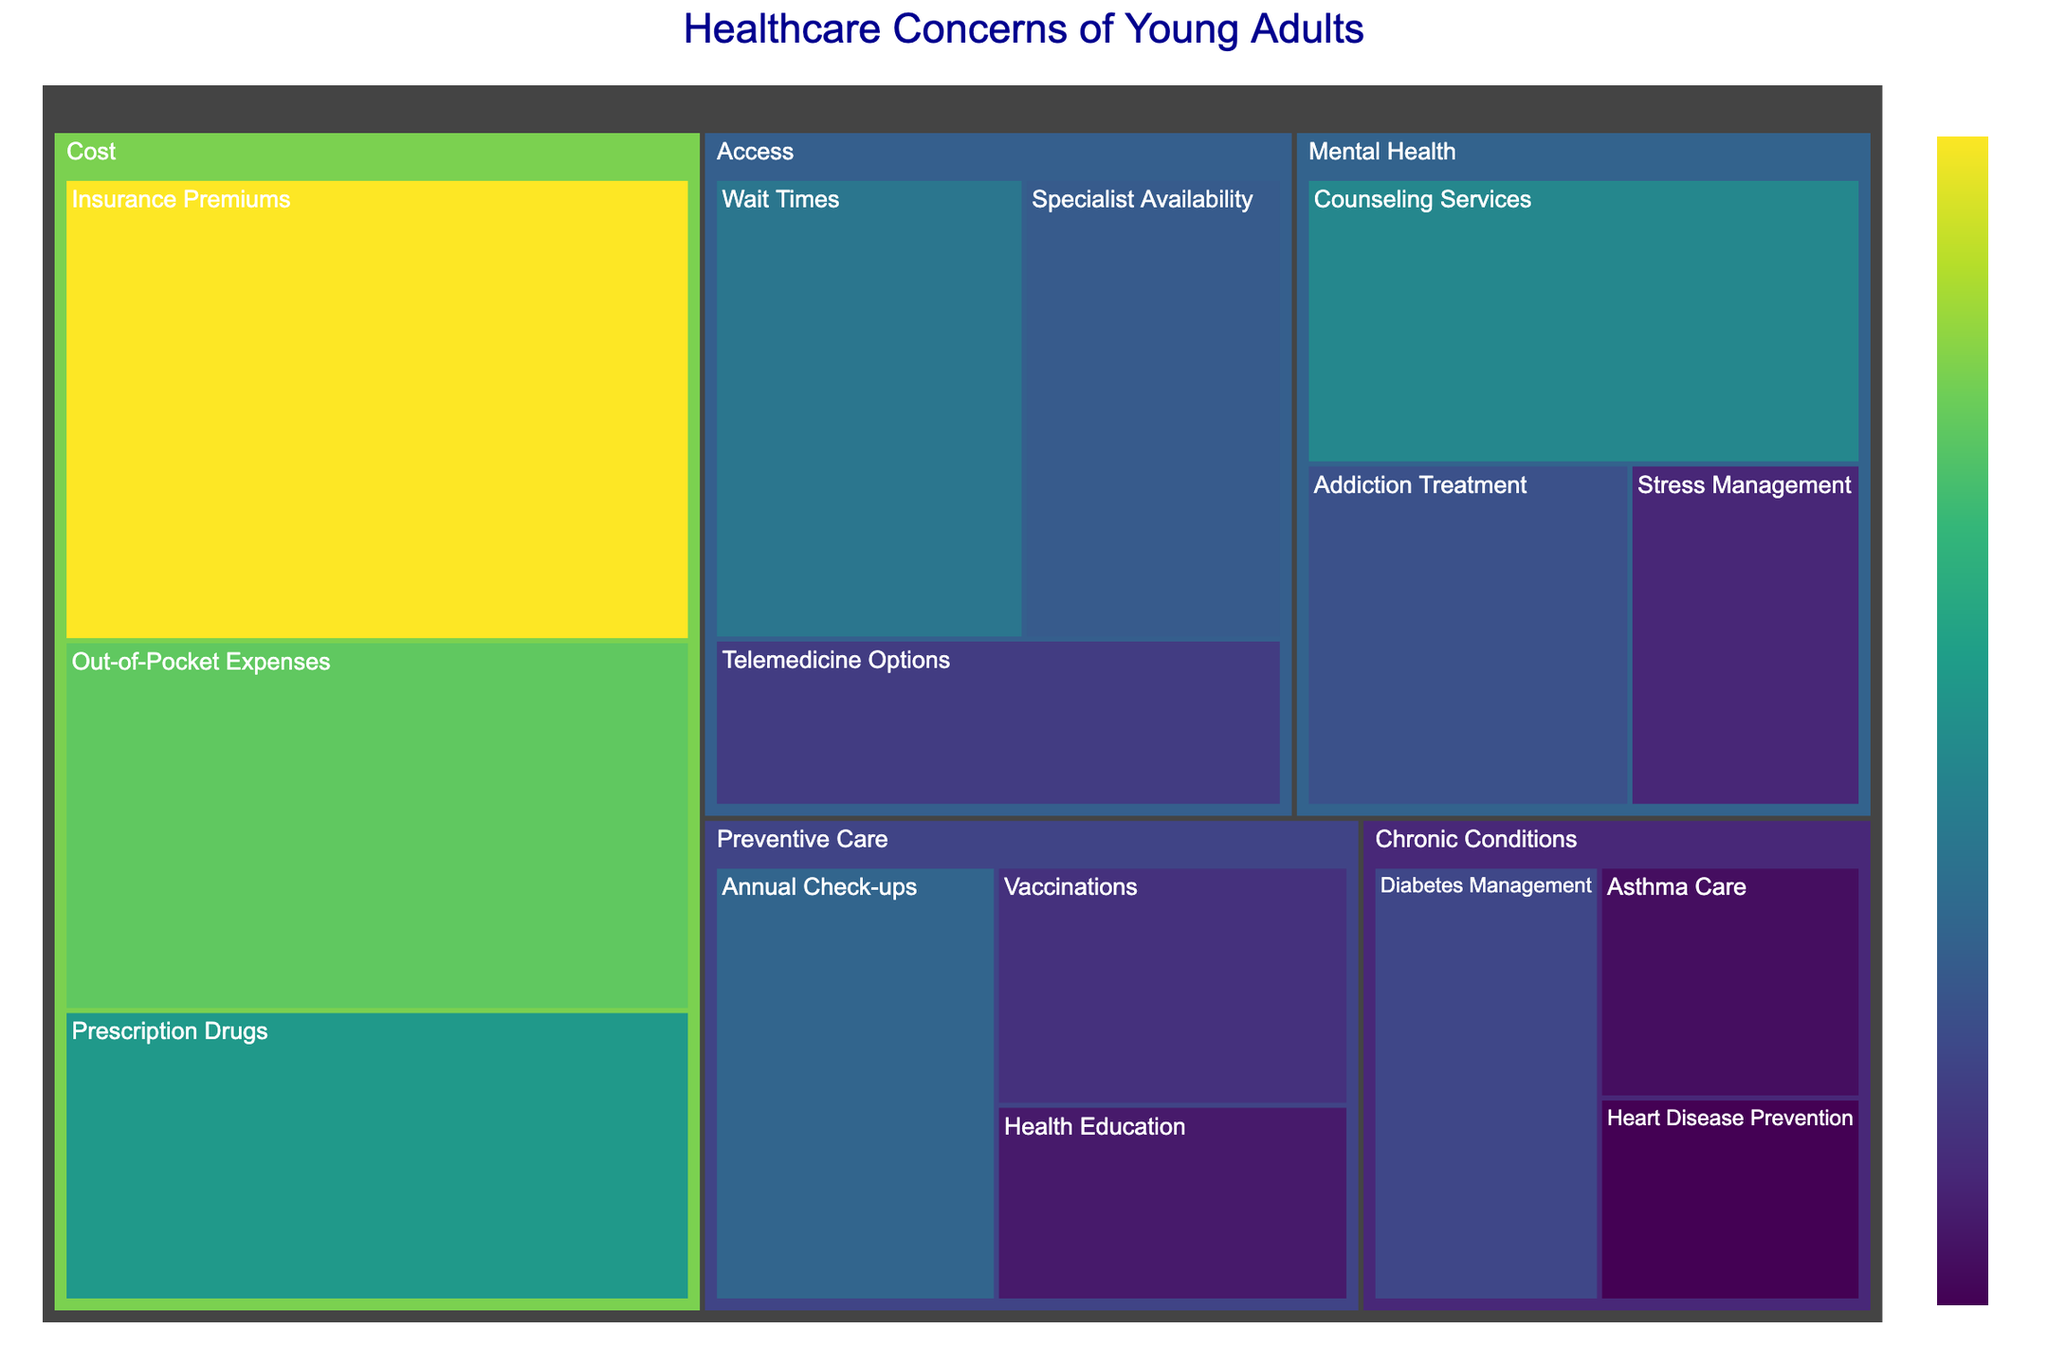What's the title of the figure? The title of a plot is typically displayed at the top to provide a summary of what the visualization represents. In this case, it is given.
Answer: Healthcare Concerns of Young Adults Which subcategory has the highest value in the 'Cost' category? To determine the subcategory with the highest value under the 'Cost' category, we look at the size of the treemap sections within 'Cost'. The largest section will have the highest value.
Answer: Insurance Premiums What is the combined value of 'Annual Check-ups' and 'Vaccinations' under 'Preventive Care'? Sum the values of 'Annual Check-ups' and 'Vaccinations' in the 'Preventive Care' category. 'Annual Check-ups' is 16 and 'Vaccinations' is 11. Therefore, the combined value is 16 + 11.
Answer: 27 Which category has the smallest overall value, and what is it? By comparing the total values of each category, we identify that 'Chronic Conditions' has the smallest overall value. The values within 'Chronic Conditions' are summed: 13 (Diabetes Management) + 8 (Asthma Care) + 7 (Heart Disease Prevention) = 28.
Answer: Chronic Conditions, 28 Compare the value of 'Telemedicine Options' to 'Addiction Treatment.' Which is higher and by how much? To compare these two values, subtract the smaller value from the larger one. 'Addiction Treatment' is 14 and 'Telemedicine Options' is 12. Thus, 14 - 12 = 2.
Answer: Addiction Treatment, 2 How does the value of 'Counseling Services' in 'Mental Health' compare to 'Wait Times' in 'Access'? Compare the numbers directly. 'Counseling Services' is 20 and 'Wait Times' is 18. Therefore, 'Counseling Services' is higher.
Answer: Counseling Services is higher What's the average value across the 'Mental Health' subcategories? To find the average value, sum the values of the 'Mental Health' subcategories and then divide by the number of subcategories. The values are 20 (Counseling Services), 14 (Addiction Treatment), and 10 (Stress Management). Therefore, (20 + 14 + 10) / 3 = 44 / 3 ≈ 14.67.
Answer: 14.67 Which subcategory has the lowest value, and what is it? To locate the subcategory with the lowest value, we look for the smallest section in the entire treemap. 'Heart Disease Prevention' in 'Chronic Conditions' has the smallest value.
Answer: Heart Disease Prevention, 7 